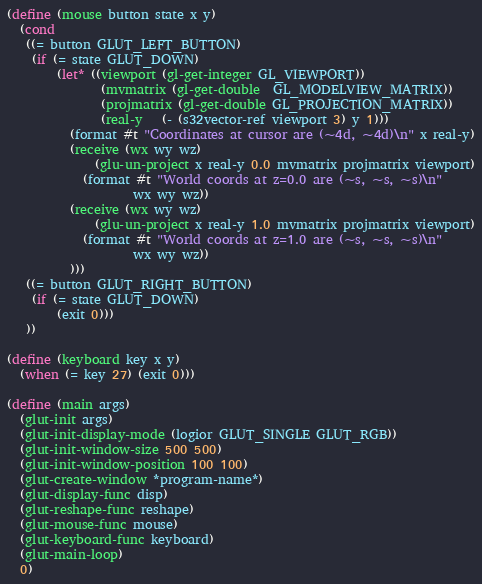Convert code to text. <code><loc_0><loc_0><loc_500><loc_500><_Scheme_>
(define (mouse button state x y)
  (cond
   ((= button GLUT_LEFT_BUTTON)
    (if (= state GLUT_DOWN)
        (let* ((viewport (gl-get-integer GL_VIEWPORT))
               (mvmatrix (gl-get-double  GL_MODELVIEW_MATRIX))
               (projmatrix (gl-get-double GL_PROJECTION_MATRIX))
               (real-y   (- (s32vector-ref viewport 3) y 1)))
          (format #t "Coordinates at cursor are (~4d, ~4d)\n" x real-y)
          (receive (wx wy wz)
              (glu-un-project x real-y 0.0 mvmatrix projmatrix viewport)
            (format #t "World coords at z=0.0 are (~s, ~s, ~s)\n"
                    wx wy wz))
          (receive (wx wy wz)
              (glu-un-project x real-y 1.0 mvmatrix projmatrix viewport)
            (format #t "World coords at z=1.0 are (~s, ~s, ~s)\n"
                    wx wy wz))
          )))
   ((= button GLUT_RIGHT_BUTTON)
    (if (= state GLUT_DOWN)
        (exit 0)))
   ))

(define (keyboard key x y)
  (when (= key 27) (exit 0)))

(define (main args)
  (glut-init args)
  (glut-init-display-mode (logior GLUT_SINGLE GLUT_RGB))
  (glut-init-window-size 500 500)
  (glut-init-window-position 100 100)
  (glut-create-window *program-name*)
  (glut-display-func disp)
  (glut-reshape-func reshape)
  (glut-mouse-func mouse)
  (glut-keyboard-func keyboard)
  (glut-main-loop)
  0)
</code> 